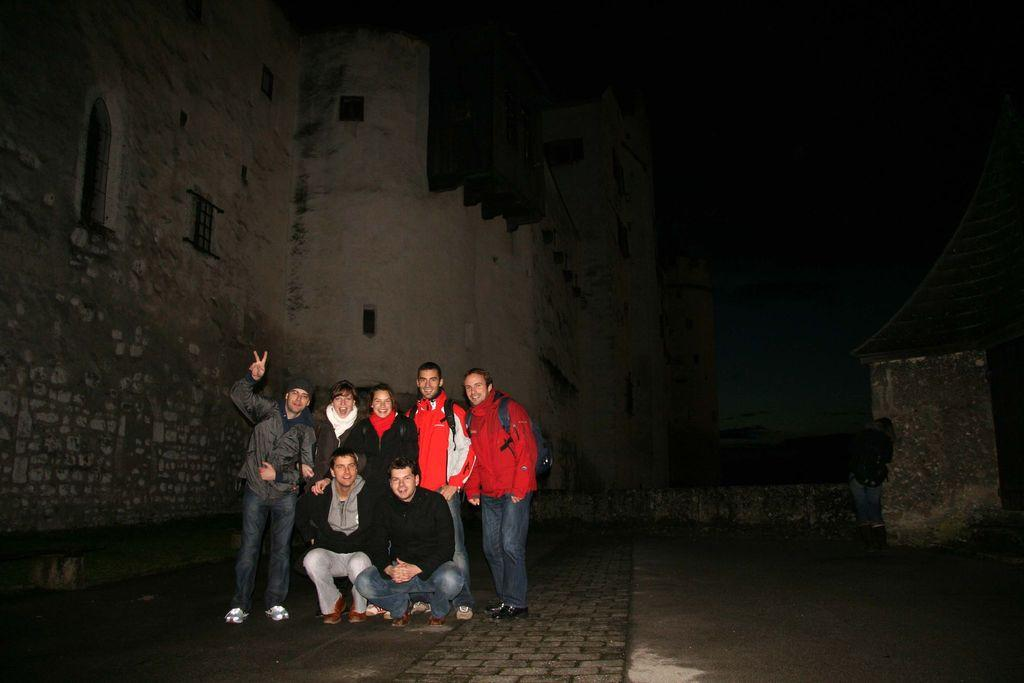What time of day was the image taken? The image was taken during night time. What can be seen in the center of the image? There are people in the center of the image. What type of structure is visible in the background of the image? There is a castle in the background of the image. What type of polish is being applied to the division in the image? There is no polish or division present in the image; it features people and a castle during night time. 